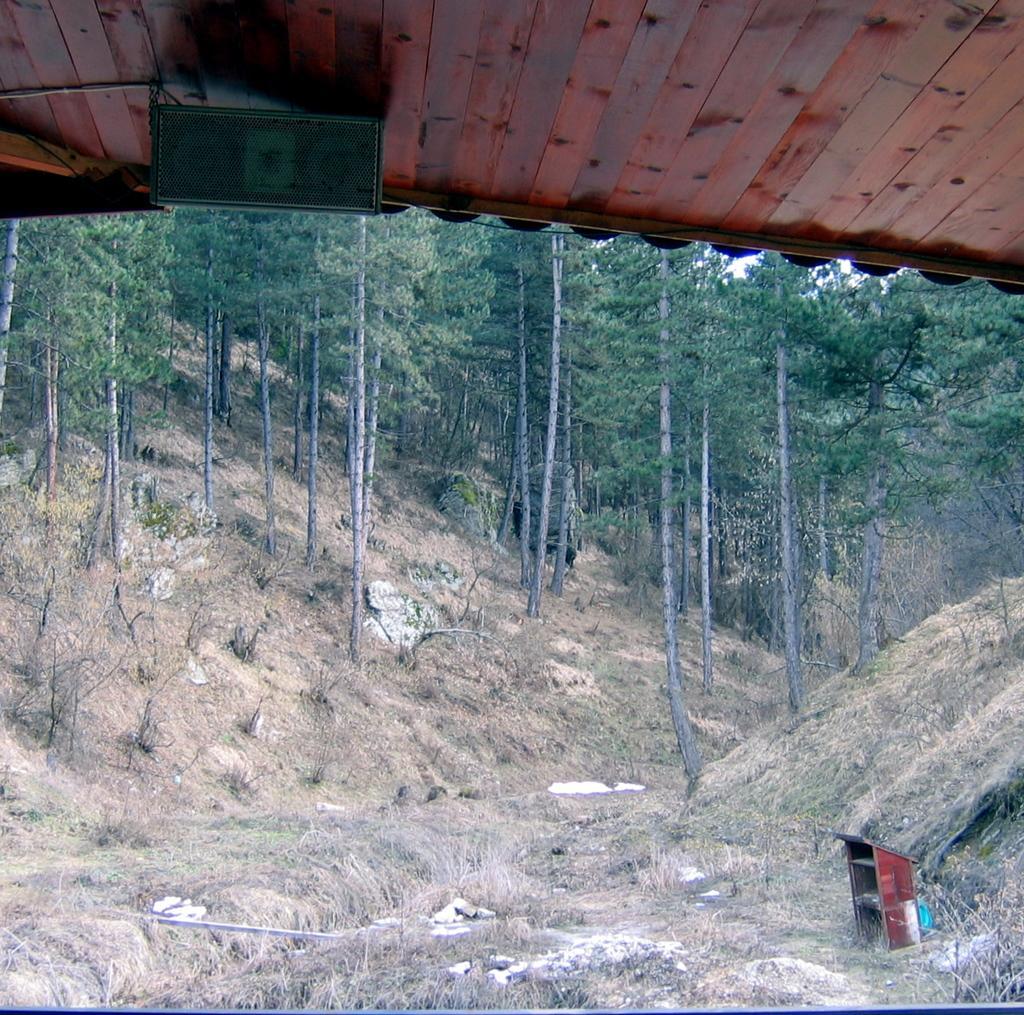How would you summarize this image in a sentence or two? At the top of the image there is ground with dry grass and small rocks. Behind them there are trees. At the top of the image there is a wooden roof with black color machine. 